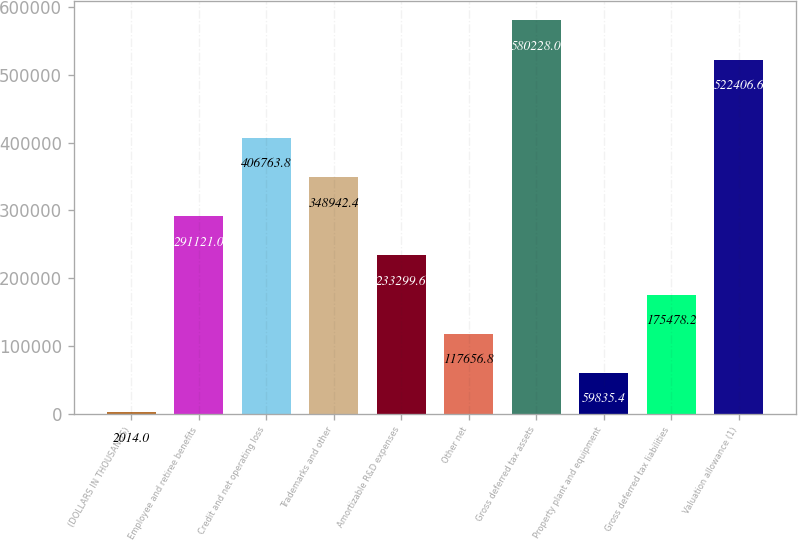Convert chart to OTSL. <chart><loc_0><loc_0><loc_500><loc_500><bar_chart><fcel>(DOLLARS IN THOUSANDS)<fcel>Employee and retiree benefits<fcel>Credit and net operating loss<fcel>Trademarks and other<fcel>Amortizable R&D expenses<fcel>Other net<fcel>Gross deferred tax assets<fcel>Property plant and equipment<fcel>Gross deferred tax liabilities<fcel>Valuation allowance (1)<nl><fcel>2014<fcel>291121<fcel>406764<fcel>348942<fcel>233300<fcel>117657<fcel>580228<fcel>59835.4<fcel>175478<fcel>522407<nl></chart> 